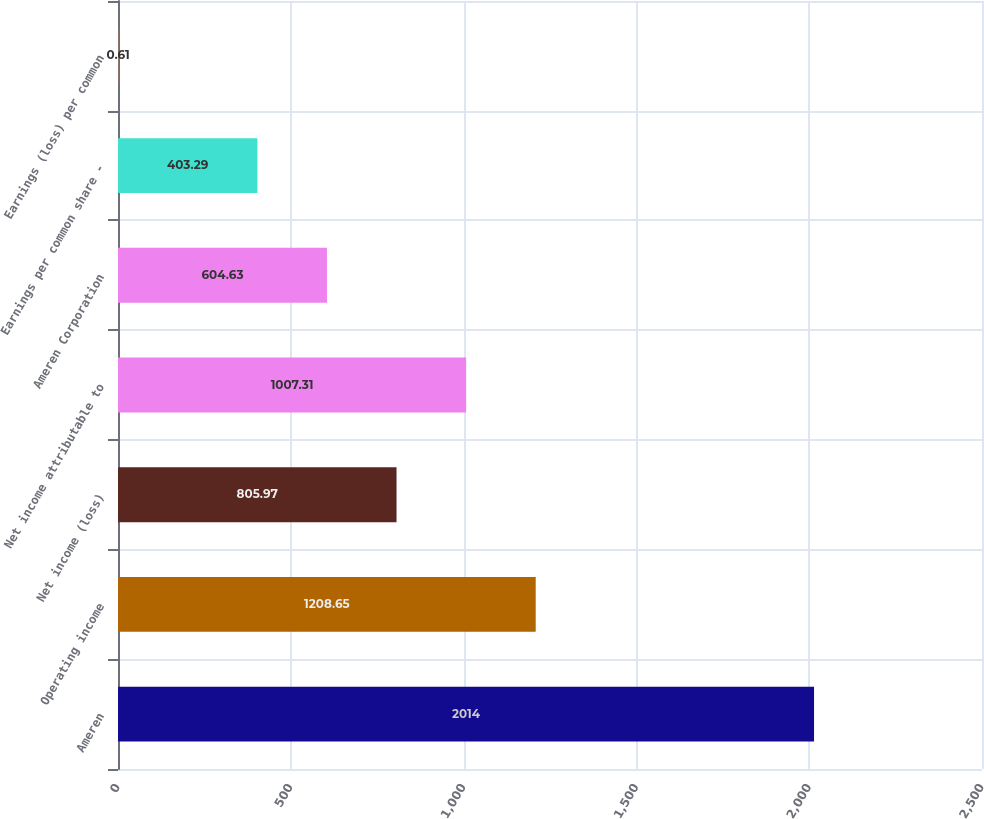Convert chart to OTSL. <chart><loc_0><loc_0><loc_500><loc_500><bar_chart><fcel>Ameren<fcel>Operating income<fcel>Net income (loss)<fcel>Net income attributable to<fcel>Ameren Corporation<fcel>Earnings per common share -<fcel>Earnings (loss) per common<nl><fcel>2014<fcel>1208.65<fcel>805.97<fcel>1007.31<fcel>604.63<fcel>403.29<fcel>0.61<nl></chart> 